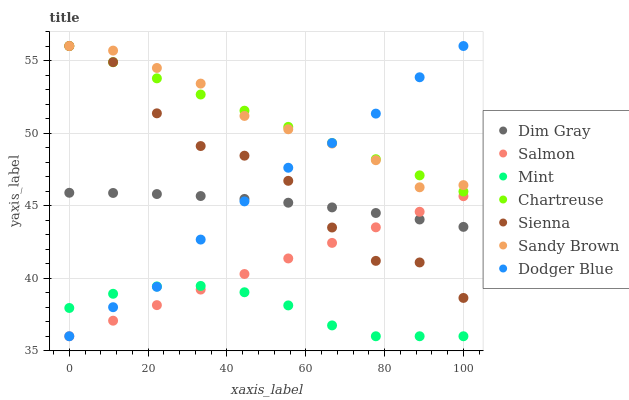Does Mint have the minimum area under the curve?
Answer yes or no. Yes. Does Sandy Brown have the maximum area under the curve?
Answer yes or no. Yes. Does Salmon have the minimum area under the curve?
Answer yes or no. No. Does Salmon have the maximum area under the curve?
Answer yes or no. No. Is Salmon the smoothest?
Answer yes or no. Yes. Is Sienna the roughest?
Answer yes or no. Yes. Is Sandy Brown the smoothest?
Answer yes or no. No. Is Sandy Brown the roughest?
Answer yes or no. No. Does Salmon have the lowest value?
Answer yes or no. Yes. Does Sandy Brown have the lowest value?
Answer yes or no. No. Does Dodger Blue have the highest value?
Answer yes or no. Yes. Does Salmon have the highest value?
Answer yes or no. No. Is Mint less than Dim Gray?
Answer yes or no. Yes. Is Sandy Brown greater than Salmon?
Answer yes or no. Yes. Does Sienna intersect Dodger Blue?
Answer yes or no. Yes. Is Sienna less than Dodger Blue?
Answer yes or no. No. Is Sienna greater than Dodger Blue?
Answer yes or no. No. Does Mint intersect Dim Gray?
Answer yes or no. No. 